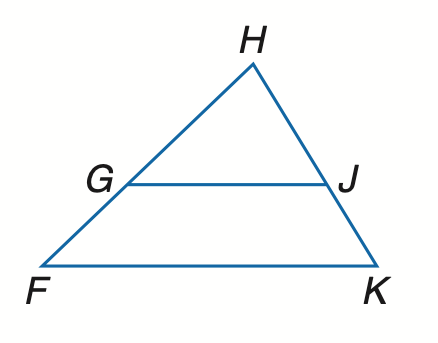Question: Find x so that G J \parallel F K. G F = 12, H G = 6, H J = 8, J K = x - 4.
Choices:
A. 12
B. 16
C. 18
D. 20
Answer with the letter. Answer: D 